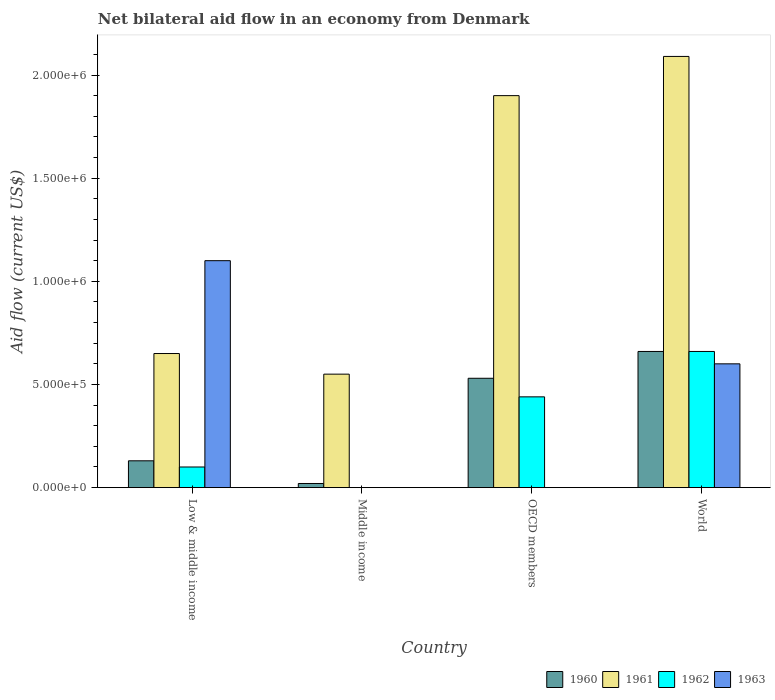How many different coloured bars are there?
Keep it short and to the point. 4. How many bars are there on the 4th tick from the right?
Give a very brief answer. 4. What is the label of the 3rd group of bars from the left?
Your answer should be compact. OECD members. Across all countries, what is the maximum net bilateral aid flow in 1961?
Keep it short and to the point. 2.09e+06. What is the total net bilateral aid flow in 1962 in the graph?
Provide a short and direct response. 1.20e+06. What is the average net bilateral aid flow in 1960 per country?
Your response must be concise. 3.35e+05. What is the difference between the net bilateral aid flow of/in 1961 and net bilateral aid flow of/in 1963 in Low & middle income?
Make the answer very short. -4.50e+05. What is the ratio of the net bilateral aid flow in 1962 in Low & middle income to that in OECD members?
Your response must be concise. 0.23. What is the difference between the highest and the second highest net bilateral aid flow in 1960?
Your answer should be very brief. 1.30e+05. In how many countries, is the net bilateral aid flow in 1963 greater than the average net bilateral aid flow in 1963 taken over all countries?
Ensure brevity in your answer.  2. Is the sum of the net bilateral aid flow in 1960 in Low & middle income and World greater than the maximum net bilateral aid flow in 1962 across all countries?
Ensure brevity in your answer.  Yes. Is it the case that in every country, the sum of the net bilateral aid flow in 1961 and net bilateral aid flow in 1962 is greater than the sum of net bilateral aid flow in 1963 and net bilateral aid flow in 1960?
Your response must be concise. No. Is it the case that in every country, the sum of the net bilateral aid flow in 1960 and net bilateral aid flow in 1961 is greater than the net bilateral aid flow in 1962?
Provide a succinct answer. Yes. How many bars are there?
Ensure brevity in your answer.  13. What is the difference between two consecutive major ticks on the Y-axis?
Offer a terse response. 5.00e+05. Are the values on the major ticks of Y-axis written in scientific E-notation?
Provide a succinct answer. Yes. Does the graph contain any zero values?
Offer a very short reply. Yes. Does the graph contain grids?
Your answer should be very brief. No. How are the legend labels stacked?
Make the answer very short. Horizontal. What is the title of the graph?
Make the answer very short. Net bilateral aid flow in an economy from Denmark. Does "1979" appear as one of the legend labels in the graph?
Your answer should be very brief. No. What is the label or title of the Y-axis?
Ensure brevity in your answer.  Aid flow (current US$). What is the Aid flow (current US$) of 1961 in Low & middle income?
Ensure brevity in your answer.  6.50e+05. What is the Aid flow (current US$) in 1962 in Low & middle income?
Your response must be concise. 1.00e+05. What is the Aid flow (current US$) in 1963 in Low & middle income?
Offer a very short reply. 1.10e+06. What is the Aid flow (current US$) of 1961 in Middle income?
Ensure brevity in your answer.  5.50e+05. What is the Aid flow (current US$) in 1962 in Middle income?
Make the answer very short. 0. What is the Aid flow (current US$) of 1960 in OECD members?
Provide a succinct answer. 5.30e+05. What is the Aid flow (current US$) of 1961 in OECD members?
Your answer should be very brief. 1.90e+06. What is the Aid flow (current US$) of 1962 in OECD members?
Provide a succinct answer. 4.40e+05. What is the Aid flow (current US$) of 1963 in OECD members?
Give a very brief answer. 0. What is the Aid flow (current US$) of 1960 in World?
Your answer should be compact. 6.60e+05. What is the Aid flow (current US$) in 1961 in World?
Provide a succinct answer. 2.09e+06. What is the Aid flow (current US$) of 1962 in World?
Your answer should be very brief. 6.60e+05. Across all countries, what is the maximum Aid flow (current US$) of 1960?
Provide a short and direct response. 6.60e+05. Across all countries, what is the maximum Aid flow (current US$) of 1961?
Provide a short and direct response. 2.09e+06. Across all countries, what is the maximum Aid flow (current US$) of 1962?
Your answer should be very brief. 6.60e+05. Across all countries, what is the maximum Aid flow (current US$) in 1963?
Give a very brief answer. 1.10e+06. Across all countries, what is the minimum Aid flow (current US$) of 1961?
Your response must be concise. 5.50e+05. What is the total Aid flow (current US$) in 1960 in the graph?
Give a very brief answer. 1.34e+06. What is the total Aid flow (current US$) of 1961 in the graph?
Your answer should be compact. 5.19e+06. What is the total Aid flow (current US$) in 1962 in the graph?
Make the answer very short. 1.20e+06. What is the total Aid flow (current US$) in 1963 in the graph?
Your answer should be compact. 1.70e+06. What is the difference between the Aid flow (current US$) of 1960 in Low & middle income and that in Middle income?
Your answer should be compact. 1.10e+05. What is the difference between the Aid flow (current US$) in 1961 in Low & middle income and that in Middle income?
Your answer should be very brief. 1.00e+05. What is the difference between the Aid flow (current US$) of 1960 in Low & middle income and that in OECD members?
Your answer should be very brief. -4.00e+05. What is the difference between the Aid flow (current US$) of 1961 in Low & middle income and that in OECD members?
Your answer should be very brief. -1.25e+06. What is the difference between the Aid flow (current US$) in 1962 in Low & middle income and that in OECD members?
Provide a short and direct response. -3.40e+05. What is the difference between the Aid flow (current US$) of 1960 in Low & middle income and that in World?
Ensure brevity in your answer.  -5.30e+05. What is the difference between the Aid flow (current US$) in 1961 in Low & middle income and that in World?
Your answer should be compact. -1.44e+06. What is the difference between the Aid flow (current US$) of 1962 in Low & middle income and that in World?
Offer a terse response. -5.60e+05. What is the difference between the Aid flow (current US$) in 1960 in Middle income and that in OECD members?
Offer a very short reply. -5.10e+05. What is the difference between the Aid flow (current US$) of 1961 in Middle income and that in OECD members?
Make the answer very short. -1.35e+06. What is the difference between the Aid flow (current US$) in 1960 in Middle income and that in World?
Give a very brief answer. -6.40e+05. What is the difference between the Aid flow (current US$) in 1961 in Middle income and that in World?
Offer a very short reply. -1.54e+06. What is the difference between the Aid flow (current US$) of 1960 in Low & middle income and the Aid flow (current US$) of 1961 in Middle income?
Give a very brief answer. -4.20e+05. What is the difference between the Aid flow (current US$) in 1960 in Low & middle income and the Aid flow (current US$) in 1961 in OECD members?
Your answer should be compact. -1.77e+06. What is the difference between the Aid flow (current US$) in 1960 in Low & middle income and the Aid flow (current US$) in 1962 in OECD members?
Your response must be concise. -3.10e+05. What is the difference between the Aid flow (current US$) of 1961 in Low & middle income and the Aid flow (current US$) of 1962 in OECD members?
Provide a short and direct response. 2.10e+05. What is the difference between the Aid flow (current US$) in 1960 in Low & middle income and the Aid flow (current US$) in 1961 in World?
Make the answer very short. -1.96e+06. What is the difference between the Aid flow (current US$) in 1960 in Low & middle income and the Aid flow (current US$) in 1962 in World?
Ensure brevity in your answer.  -5.30e+05. What is the difference between the Aid flow (current US$) of 1960 in Low & middle income and the Aid flow (current US$) of 1963 in World?
Keep it short and to the point. -4.70e+05. What is the difference between the Aid flow (current US$) in 1961 in Low & middle income and the Aid flow (current US$) in 1963 in World?
Ensure brevity in your answer.  5.00e+04. What is the difference between the Aid flow (current US$) of 1962 in Low & middle income and the Aid flow (current US$) of 1963 in World?
Your answer should be compact. -5.00e+05. What is the difference between the Aid flow (current US$) in 1960 in Middle income and the Aid flow (current US$) in 1961 in OECD members?
Offer a very short reply. -1.88e+06. What is the difference between the Aid flow (current US$) of 1960 in Middle income and the Aid flow (current US$) of 1962 in OECD members?
Give a very brief answer. -4.20e+05. What is the difference between the Aid flow (current US$) in 1961 in Middle income and the Aid flow (current US$) in 1962 in OECD members?
Give a very brief answer. 1.10e+05. What is the difference between the Aid flow (current US$) of 1960 in Middle income and the Aid flow (current US$) of 1961 in World?
Your response must be concise. -2.07e+06. What is the difference between the Aid flow (current US$) of 1960 in Middle income and the Aid flow (current US$) of 1962 in World?
Provide a short and direct response. -6.40e+05. What is the difference between the Aid flow (current US$) in 1960 in Middle income and the Aid flow (current US$) in 1963 in World?
Ensure brevity in your answer.  -5.80e+05. What is the difference between the Aid flow (current US$) in 1961 in Middle income and the Aid flow (current US$) in 1963 in World?
Offer a terse response. -5.00e+04. What is the difference between the Aid flow (current US$) in 1960 in OECD members and the Aid flow (current US$) in 1961 in World?
Ensure brevity in your answer.  -1.56e+06. What is the difference between the Aid flow (current US$) of 1961 in OECD members and the Aid flow (current US$) of 1962 in World?
Give a very brief answer. 1.24e+06. What is the difference between the Aid flow (current US$) of 1961 in OECD members and the Aid flow (current US$) of 1963 in World?
Provide a short and direct response. 1.30e+06. What is the difference between the Aid flow (current US$) of 1962 in OECD members and the Aid flow (current US$) of 1963 in World?
Your response must be concise. -1.60e+05. What is the average Aid flow (current US$) in 1960 per country?
Offer a very short reply. 3.35e+05. What is the average Aid flow (current US$) in 1961 per country?
Provide a short and direct response. 1.30e+06. What is the average Aid flow (current US$) in 1963 per country?
Ensure brevity in your answer.  4.25e+05. What is the difference between the Aid flow (current US$) in 1960 and Aid flow (current US$) in 1961 in Low & middle income?
Your answer should be compact. -5.20e+05. What is the difference between the Aid flow (current US$) of 1960 and Aid flow (current US$) of 1963 in Low & middle income?
Offer a very short reply. -9.70e+05. What is the difference between the Aid flow (current US$) of 1961 and Aid flow (current US$) of 1962 in Low & middle income?
Keep it short and to the point. 5.50e+05. What is the difference between the Aid flow (current US$) of 1961 and Aid flow (current US$) of 1963 in Low & middle income?
Offer a very short reply. -4.50e+05. What is the difference between the Aid flow (current US$) of 1962 and Aid flow (current US$) of 1963 in Low & middle income?
Provide a short and direct response. -1.00e+06. What is the difference between the Aid flow (current US$) of 1960 and Aid flow (current US$) of 1961 in Middle income?
Your answer should be compact. -5.30e+05. What is the difference between the Aid flow (current US$) in 1960 and Aid flow (current US$) in 1961 in OECD members?
Offer a very short reply. -1.37e+06. What is the difference between the Aid flow (current US$) in 1960 and Aid flow (current US$) in 1962 in OECD members?
Your answer should be compact. 9.00e+04. What is the difference between the Aid flow (current US$) in 1961 and Aid flow (current US$) in 1962 in OECD members?
Provide a succinct answer. 1.46e+06. What is the difference between the Aid flow (current US$) of 1960 and Aid flow (current US$) of 1961 in World?
Your answer should be very brief. -1.43e+06. What is the difference between the Aid flow (current US$) in 1961 and Aid flow (current US$) in 1962 in World?
Offer a very short reply. 1.43e+06. What is the difference between the Aid flow (current US$) of 1961 and Aid flow (current US$) of 1963 in World?
Give a very brief answer. 1.49e+06. What is the ratio of the Aid flow (current US$) of 1961 in Low & middle income to that in Middle income?
Ensure brevity in your answer.  1.18. What is the ratio of the Aid flow (current US$) in 1960 in Low & middle income to that in OECD members?
Keep it short and to the point. 0.25. What is the ratio of the Aid flow (current US$) in 1961 in Low & middle income to that in OECD members?
Your answer should be very brief. 0.34. What is the ratio of the Aid flow (current US$) of 1962 in Low & middle income to that in OECD members?
Provide a succinct answer. 0.23. What is the ratio of the Aid flow (current US$) of 1960 in Low & middle income to that in World?
Provide a succinct answer. 0.2. What is the ratio of the Aid flow (current US$) of 1961 in Low & middle income to that in World?
Ensure brevity in your answer.  0.31. What is the ratio of the Aid flow (current US$) in 1962 in Low & middle income to that in World?
Your answer should be very brief. 0.15. What is the ratio of the Aid flow (current US$) in 1963 in Low & middle income to that in World?
Ensure brevity in your answer.  1.83. What is the ratio of the Aid flow (current US$) in 1960 in Middle income to that in OECD members?
Keep it short and to the point. 0.04. What is the ratio of the Aid flow (current US$) of 1961 in Middle income to that in OECD members?
Your answer should be compact. 0.29. What is the ratio of the Aid flow (current US$) of 1960 in Middle income to that in World?
Provide a short and direct response. 0.03. What is the ratio of the Aid flow (current US$) in 1961 in Middle income to that in World?
Offer a very short reply. 0.26. What is the ratio of the Aid flow (current US$) in 1960 in OECD members to that in World?
Offer a terse response. 0.8. What is the ratio of the Aid flow (current US$) in 1962 in OECD members to that in World?
Keep it short and to the point. 0.67. What is the difference between the highest and the second highest Aid flow (current US$) of 1962?
Your response must be concise. 2.20e+05. What is the difference between the highest and the lowest Aid flow (current US$) in 1960?
Make the answer very short. 6.40e+05. What is the difference between the highest and the lowest Aid flow (current US$) in 1961?
Ensure brevity in your answer.  1.54e+06. What is the difference between the highest and the lowest Aid flow (current US$) in 1962?
Offer a very short reply. 6.60e+05. What is the difference between the highest and the lowest Aid flow (current US$) in 1963?
Your response must be concise. 1.10e+06. 